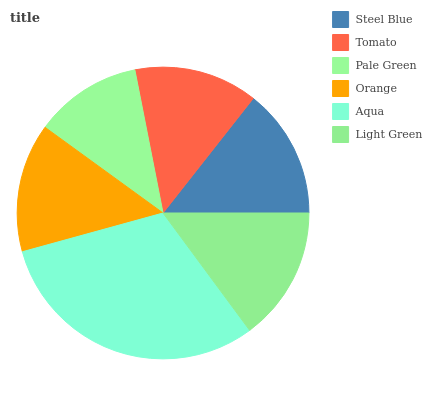Is Pale Green the minimum?
Answer yes or no. Yes. Is Aqua the maximum?
Answer yes or no. Yes. Is Tomato the minimum?
Answer yes or no. No. Is Tomato the maximum?
Answer yes or no. No. Is Steel Blue greater than Tomato?
Answer yes or no. Yes. Is Tomato less than Steel Blue?
Answer yes or no. Yes. Is Tomato greater than Steel Blue?
Answer yes or no. No. Is Steel Blue less than Tomato?
Answer yes or no. No. Is Steel Blue the high median?
Answer yes or no. Yes. Is Orange the low median?
Answer yes or no. Yes. Is Aqua the high median?
Answer yes or no. No. Is Light Green the low median?
Answer yes or no. No. 